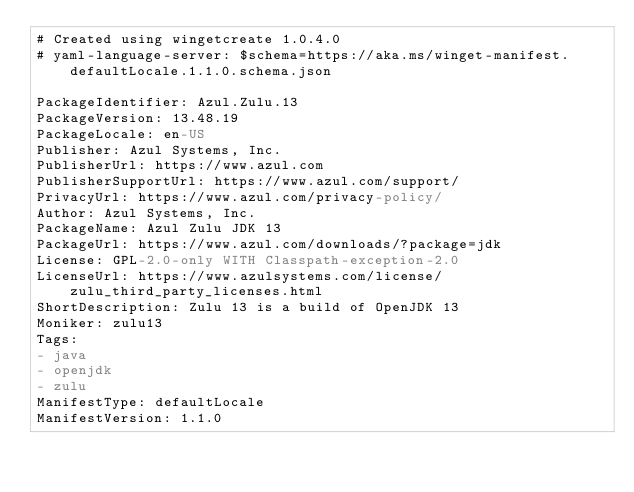Convert code to text. <code><loc_0><loc_0><loc_500><loc_500><_YAML_># Created using wingetcreate 1.0.4.0
# yaml-language-server: $schema=https://aka.ms/winget-manifest.defaultLocale.1.1.0.schema.json

PackageIdentifier: Azul.Zulu.13
PackageVersion: 13.48.19
PackageLocale: en-US
Publisher: Azul Systems, Inc.
PublisherUrl: https://www.azul.com
PublisherSupportUrl: https://www.azul.com/support/
PrivacyUrl: https://www.azul.com/privacy-policy/
Author: Azul Systems, Inc.
PackageName: Azul Zulu JDK 13
PackageUrl: https://www.azul.com/downloads/?package=jdk
License: GPL-2.0-only WITH Classpath-exception-2.0
LicenseUrl: https://www.azulsystems.com/license/zulu_third_party_licenses.html
ShortDescription: Zulu 13 is a build of OpenJDK 13
Moniker: zulu13
Tags:
- java
- openjdk
- zulu
ManifestType: defaultLocale
ManifestVersion: 1.1.0

</code> 